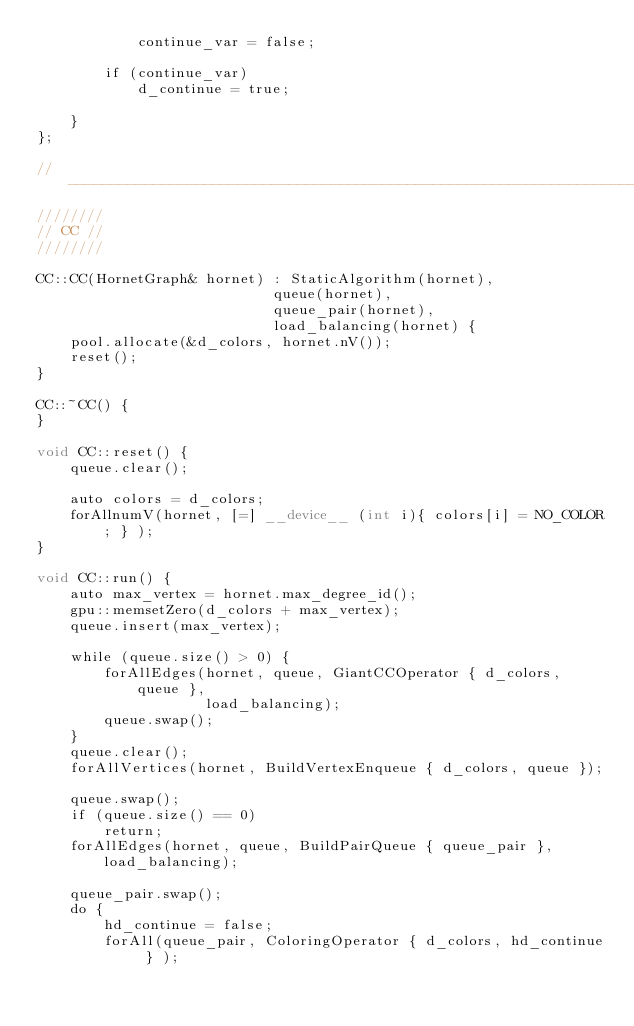Convert code to text. <code><loc_0><loc_0><loc_500><loc_500><_Cuda_>            continue_var = false;

        if (continue_var)
            d_continue = true;

    }
};

//------------------------------------------------------------------------------
////////
// CC //
////////

CC::CC(HornetGraph& hornet) : StaticAlgorithm(hornet),
                            queue(hornet),
                            queue_pair(hornet),
                            load_balancing(hornet) {
    pool.allocate(&d_colors, hornet.nV());
    reset();
}

CC::~CC() {
}

void CC::reset() {
    queue.clear();

    auto colors = d_colors;
    forAllnumV(hornet, [=] __device__ (int i){ colors[i] = NO_COLOR; } );
}

void CC::run() {
    auto max_vertex = hornet.max_degree_id();
    gpu::memsetZero(d_colors + max_vertex);
    queue.insert(max_vertex);

    while (queue.size() > 0) {
        forAllEdges(hornet, queue, GiantCCOperator { d_colors, queue },
                    load_balancing);
        queue.swap();
    }
    queue.clear();
    forAllVertices(hornet, BuildVertexEnqueue { d_colors, queue });

    queue.swap();
    if (queue.size() == 0)
        return;
    forAllEdges(hornet, queue, BuildPairQueue { queue_pair }, load_balancing);

    queue_pair.swap();
    do {
        hd_continue = false;
        forAll(queue_pair, ColoringOperator { d_colors, hd_continue } );</code> 